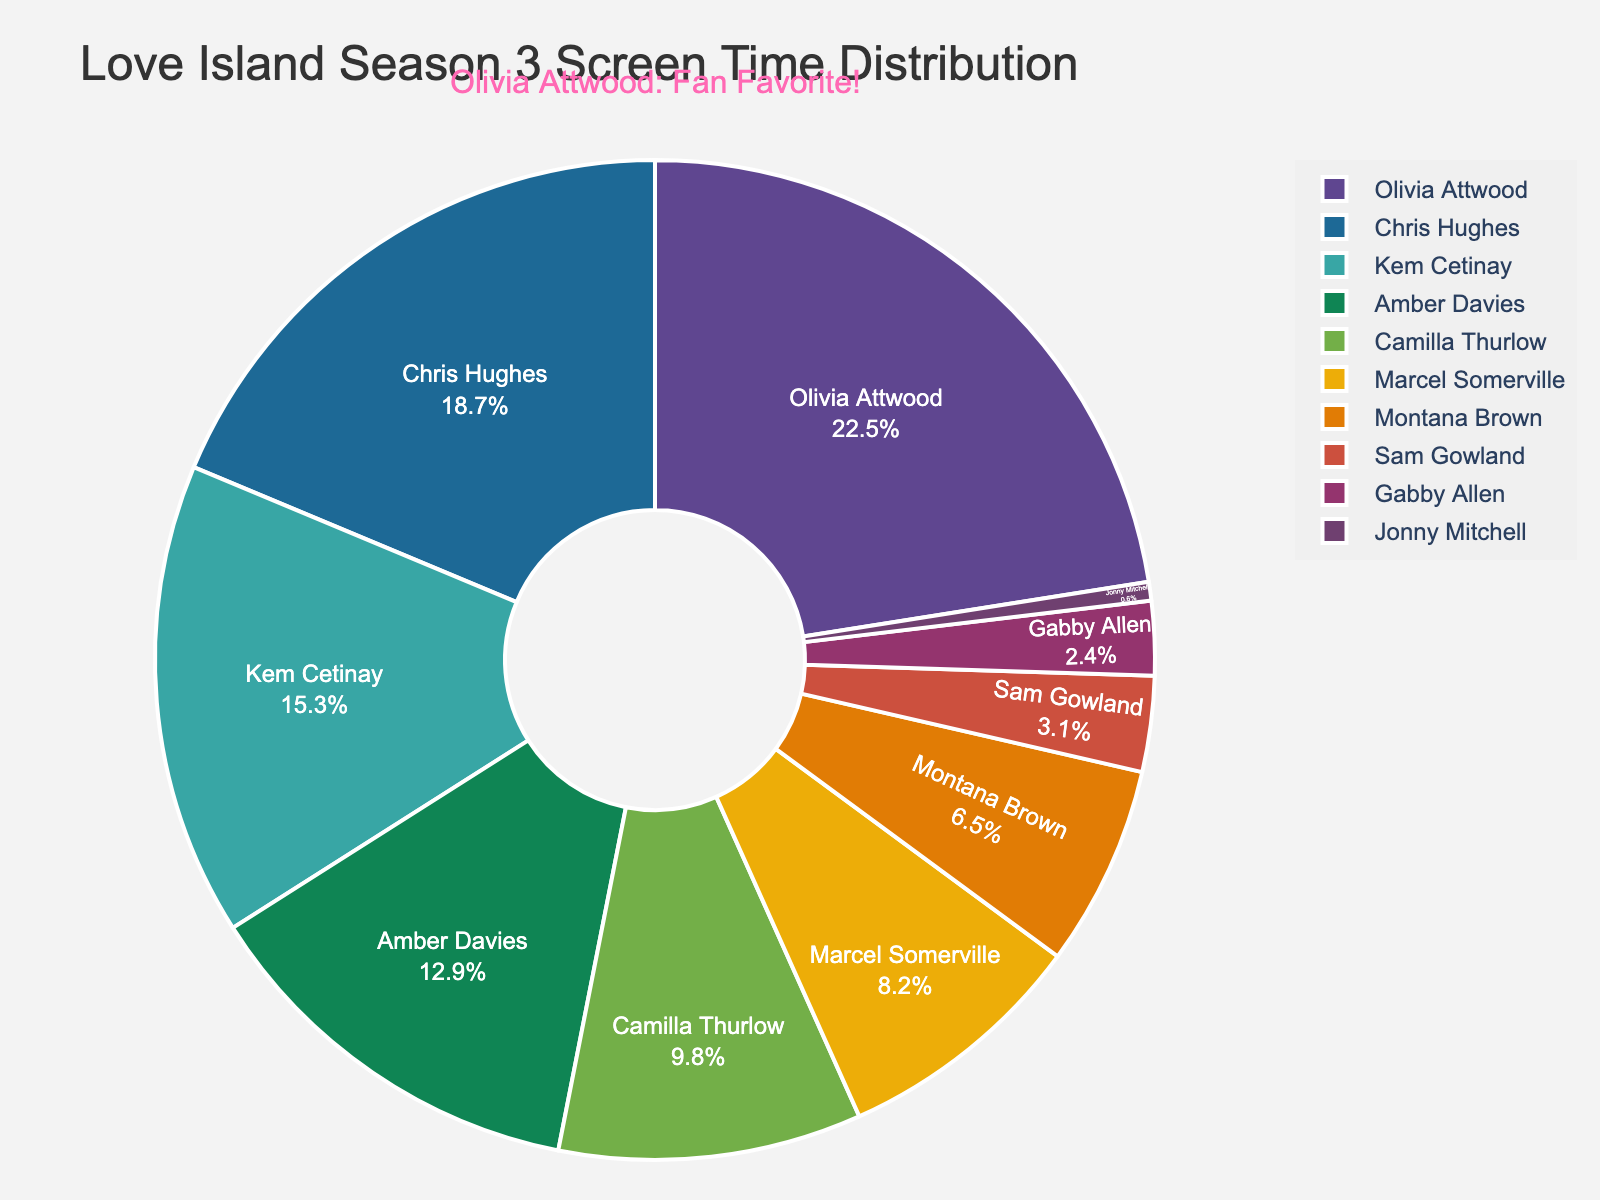What percentage of screen time does Olivia Attwood have? Olivia Attwood has a screen time percentage listed in the figure. Simply refer to her segment.
Answer: 22.5% Which cast member has the least amount of screen time? Look for the segment with the smallest percentage, which represents the cast member with the least screen time.
Answer: Jonny Mitchell What is the combined screen time percentage for Chris Hughes and Kem Cetinay? Add the screen time percentages for Chris Hughes (18.7%) and Kem Cetinay (15.3%). 18.7 + 15.3 = 34.
Answer: 34% Who has more screen time, Amber Davies or Marcel Somerville? Compare the screen time percentages of Amber Davies (12.9%) and Marcel Somerville (8.2%). 12.9 > 8.2, so Amber Davies has more.
Answer: Amber Davies What is the difference in screen time percentage between Olivia Attwood and Gabby Allen? Calculate the difference: Olivia Attwood (22.5%) - Gabby Allen (2.4%). 22.5 - 2.4 = 20.1.
Answer: 20.1% What is the average screen time percentage of Montana Brown, Sam Gowland, and Gabby Allen? Add the percentages and then divide by the number of cast members: (6.5% + 3.1% + 2.4%) / 3 = 12 / 3 = 4.
Answer: 4% Which cast members collectively represent more than 50% of the screen time? Add the screen time percentages from the top until the sum exceeds 50%. Olivia Attwood (22.5%) + Chris Hughes (18.7%) + Kem Cetinay (15.3%) = 56.5%.
Answer: Olivia Attwood, Chris Hughes, Kem Cetinay How much more screen time does Olivia Attwood have compared to Sam Gowland? Calculate the difference: Olivia Attwood (22.5%) - Sam Gowland (3.1%). 22.5 - 3.1 = 19.4.
Answer: 19.4% Which cast member has the closest screen time percentage to Camilla Thurlow? Compare the screen time percentage of Camilla Thurlow (9.8%) with other cast members. Marcel Somerville (8.2%) is closest.
Answer: Marcel Somerville 